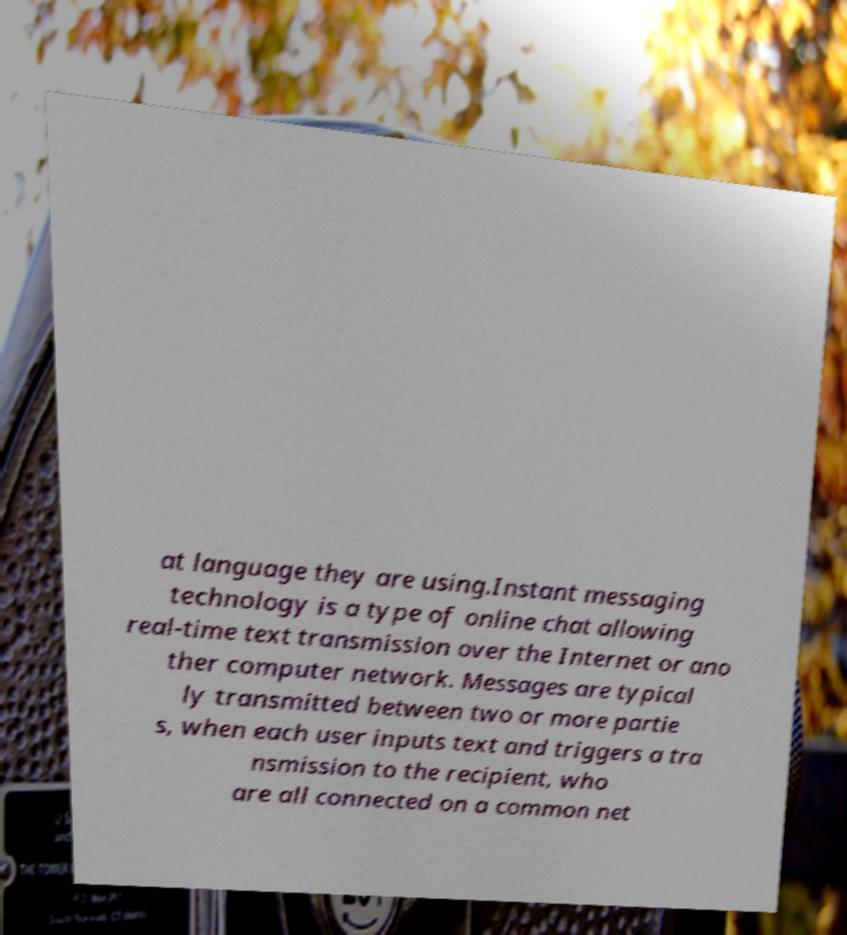Can you accurately transcribe the text from the provided image for me? at language they are using.Instant messaging technology is a type of online chat allowing real-time text transmission over the Internet or ano ther computer network. Messages are typical ly transmitted between two or more partie s, when each user inputs text and triggers a tra nsmission to the recipient, who are all connected on a common net 